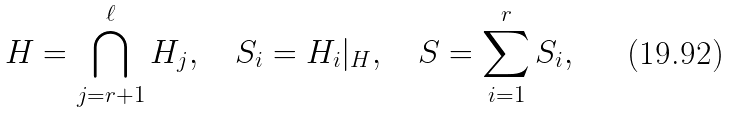Convert formula to latex. <formula><loc_0><loc_0><loc_500><loc_500>H = \bigcap _ { j = r + 1 } ^ { \ell } H _ { j } , \quad S _ { i } = H _ { i } | _ { H } , \quad S = \sum _ { i = 1 } ^ { r } S _ { i } ,</formula> 